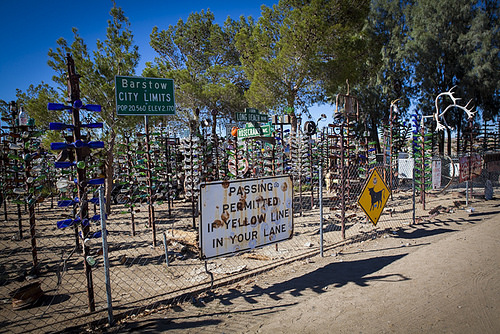<image>
Is there a trees to the right of the fence? No. The trees is not to the right of the fence. The horizontal positioning shows a different relationship. Where is the sign in relation to the sign? Is it next to the sign? Yes. The sign is positioned adjacent to the sign, located nearby in the same general area. 